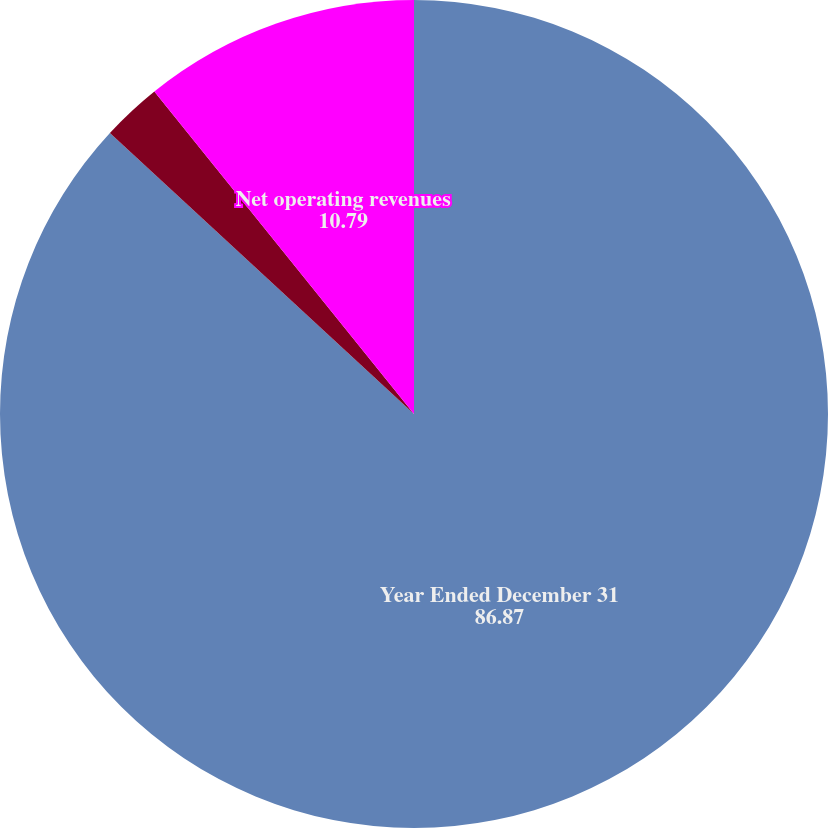Convert chart. <chart><loc_0><loc_0><loc_500><loc_500><pie_chart><fcel>Year Ended December 31<fcel>Concentrate operations 1<fcel>Net operating revenues<nl><fcel>86.87%<fcel>2.34%<fcel>10.79%<nl></chart> 